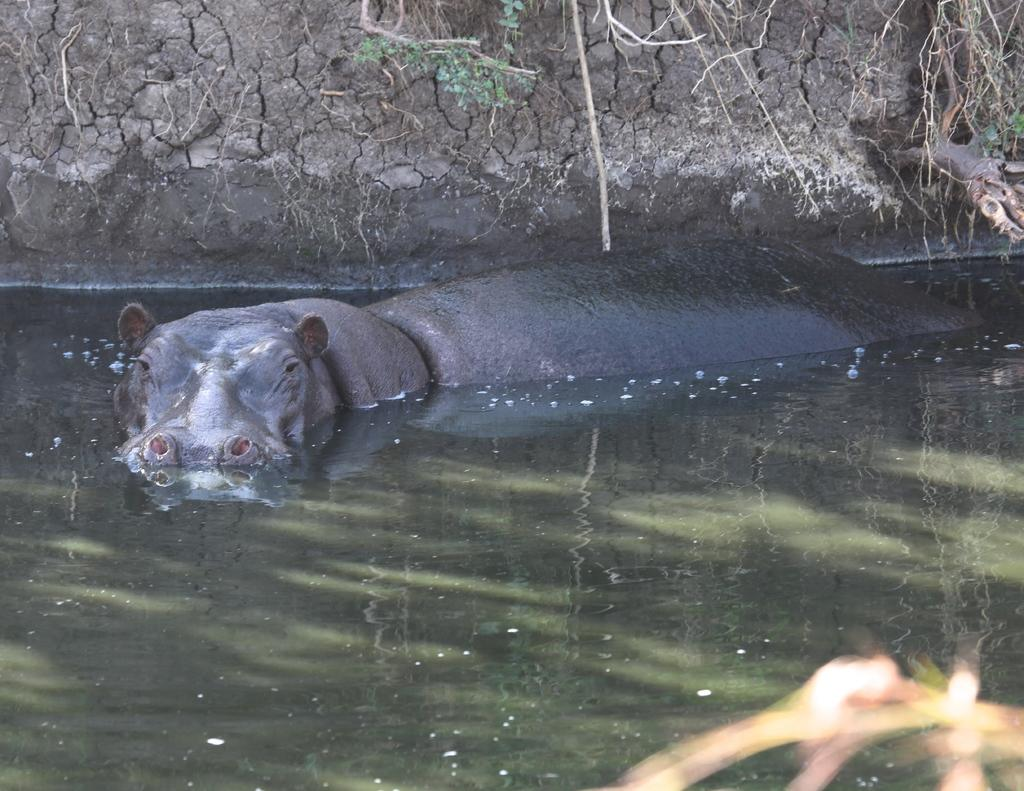What is in the water in the image? There is an animal in the water in the image. What can be seen at the back of the image? There is mud at the back of the image. What type of plant is present in the image? There is a tree in the image. What is visible at the bottom of the image? There is water visible at the bottom of the image. How many quarters are visible in the image? There are no quarters present in the image. What type of field is shown in the image? There is no field present in the image; it features an animal in the water, mud, a tree, and water at the bottom. 